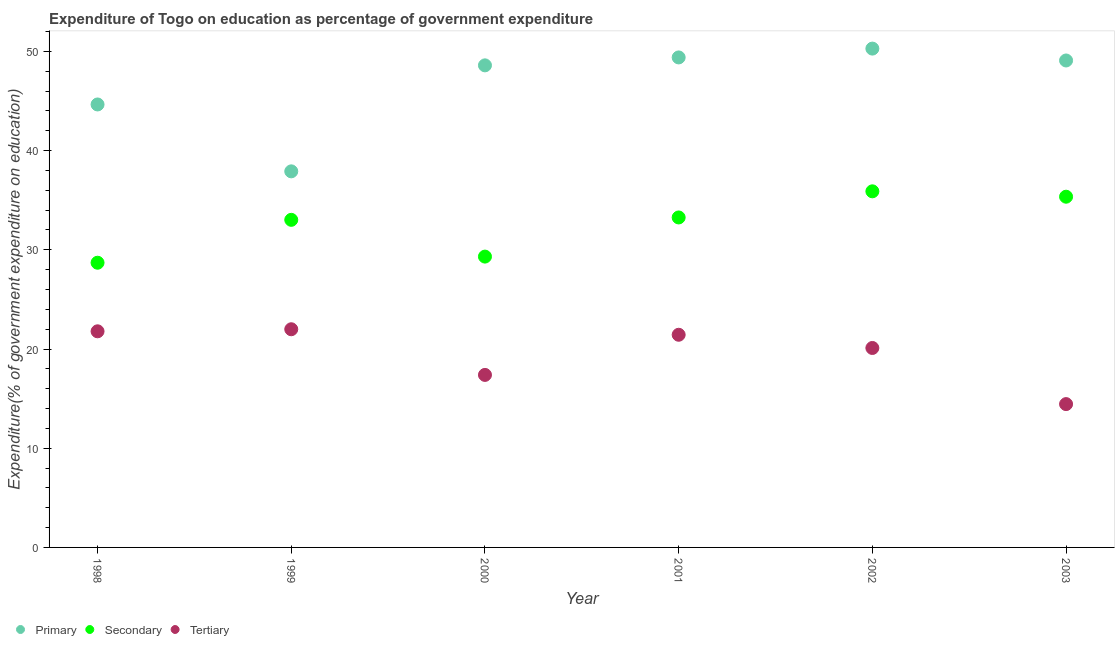What is the expenditure on secondary education in 1998?
Offer a terse response. 28.7. Across all years, what is the maximum expenditure on primary education?
Provide a short and direct response. 50.28. Across all years, what is the minimum expenditure on secondary education?
Your answer should be compact. 28.7. In which year was the expenditure on primary education minimum?
Offer a terse response. 1999. What is the total expenditure on primary education in the graph?
Your response must be concise. 279.89. What is the difference between the expenditure on secondary education in 2000 and that in 2001?
Provide a succinct answer. -3.95. What is the difference between the expenditure on primary education in 2001 and the expenditure on secondary education in 2000?
Ensure brevity in your answer.  20.08. What is the average expenditure on secondary education per year?
Give a very brief answer. 32.59. In the year 2000, what is the difference between the expenditure on secondary education and expenditure on primary education?
Your answer should be compact. -19.28. What is the ratio of the expenditure on tertiary education in 1999 to that in 2002?
Ensure brevity in your answer.  1.09. Is the expenditure on tertiary education in 2001 less than that in 2002?
Make the answer very short. No. What is the difference between the highest and the second highest expenditure on primary education?
Ensure brevity in your answer.  0.89. What is the difference between the highest and the lowest expenditure on secondary education?
Ensure brevity in your answer.  7.2. In how many years, is the expenditure on tertiary education greater than the average expenditure on tertiary education taken over all years?
Your answer should be compact. 4. Is it the case that in every year, the sum of the expenditure on primary education and expenditure on secondary education is greater than the expenditure on tertiary education?
Give a very brief answer. Yes. How many dotlines are there?
Your answer should be very brief. 3. How many years are there in the graph?
Your answer should be compact. 6. What is the difference between two consecutive major ticks on the Y-axis?
Ensure brevity in your answer.  10. Are the values on the major ticks of Y-axis written in scientific E-notation?
Keep it short and to the point. No. Does the graph contain grids?
Offer a terse response. No. Where does the legend appear in the graph?
Keep it short and to the point. Bottom left. How many legend labels are there?
Keep it short and to the point. 3. How are the legend labels stacked?
Your answer should be compact. Horizontal. What is the title of the graph?
Ensure brevity in your answer.  Expenditure of Togo on education as percentage of government expenditure. What is the label or title of the Y-axis?
Provide a succinct answer. Expenditure(% of government expenditure on education). What is the Expenditure(% of government expenditure on education) of Primary in 1998?
Ensure brevity in your answer.  44.65. What is the Expenditure(% of government expenditure on education) of Secondary in 1998?
Provide a short and direct response. 28.7. What is the Expenditure(% of government expenditure on education) of Tertiary in 1998?
Provide a short and direct response. 21.78. What is the Expenditure(% of government expenditure on education) of Primary in 1999?
Provide a short and direct response. 37.91. What is the Expenditure(% of government expenditure on education) in Secondary in 1999?
Offer a very short reply. 33.02. What is the Expenditure(% of government expenditure on education) of Tertiary in 1999?
Offer a terse response. 21.99. What is the Expenditure(% of government expenditure on education) in Primary in 2000?
Offer a very short reply. 48.59. What is the Expenditure(% of government expenditure on education) in Secondary in 2000?
Offer a terse response. 29.31. What is the Expenditure(% of government expenditure on education) in Tertiary in 2000?
Offer a terse response. 17.39. What is the Expenditure(% of government expenditure on education) of Primary in 2001?
Provide a succinct answer. 49.39. What is the Expenditure(% of government expenditure on education) of Secondary in 2001?
Provide a succinct answer. 33.26. What is the Expenditure(% of government expenditure on education) of Tertiary in 2001?
Provide a short and direct response. 21.43. What is the Expenditure(% of government expenditure on education) of Primary in 2002?
Offer a very short reply. 50.28. What is the Expenditure(% of government expenditure on education) of Secondary in 2002?
Keep it short and to the point. 35.89. What is the Expenditure(% of government expenditure on education) of Tertiary in 2002?
Offer a very short reply. 20.1. What is the Expenditure(% of government expenditure on education) of Primary in 2003?
Provide a short and direct response. 49.08. What is the Expenditure(% of government expenditure on education) in Secondary in 2003?
Provide a succinct answer. 35.35. What is the Expenditure(% of government expenditure on education) of Tertiary in 2003?
Ensure brevity in your answer.  14.45. Across all years, what is the maximum Expenditure(% of government expenditure on education) in Primary?
Your response must be concise. 50.28. Across all years, what is the maximum Expenditure(% of government expenditure on education) in Secondary?
Your answer should be compact. 35.89. Across all years, what is the maximum Expenditure(% of government expenditure on education) in Tertiary?
Your answer should be compact. 21.99. Across all years, what is the minimum Expenditure(% of government expenditure on education) in Primary?
Provide a short and direct response. 37.91. Across all years, what is the minimum Expenditure(% of government expenditure on education) in Secondary?
Your response must be concise. 28.7. Across all years, what is the minimum Expenditure(% of government expenditure on education) in Tertiary?
Ensure brevity in your answer.  14.45. What is the total Expenditure(% of government expenditure on education) in Primary in the graph?
Offer a terse response. 279.89. What is the total Expenditure(% of government expenditure on education) in Secondary in the graph?
Ensure brevity in your answer.  195.53. What is the total Expenditure(% of government expenditure on education) in Tertiary in the graph?
Offer a very short reply. 117.15. What is the difference between the Expenditure(% of government expenditure on education) in Primary in 1998 and that in 1999?
Your response must be concise. 6.74. What is the difference between the Expenditure(% of government expenditure on education) in Secondary in 1998 and that in 1999?
Provide a short and direct response. -4.32. What is the difference between the Expenditure(% of government expenditure on education) of Tertiary in 1998 and that in 1999?
Your response must be concise. -0.21. What is the difference between the Expenditure(% of government expenditure on education) in Primary in 1998 and that in 2000?
Offer a terse response. -3.94. What is the difference between the Expenditure(% of government expenditure on education) of Secondary in 1998 and that in 2000?
Your answer should be very brief. -0.62. What is the difference between the Expenditure(% of government expenditure on education) in Tertiary in 1998 and that in 2000?
Your response must be concise. 4.4. What is the difference between the Expenditure(% of government expenditure on education) of Primary in 1998 and that in 2001?
Make the answer very short. -4.74. What is the difference between the Expenditure(% of government expenditure on education) in Secondary in 1998 and that in 2001?
Offer a very short reply. -4.56. What is the difference between the Expenditure(% of government expenditure on education) of Tertiary in 1998 and that in 2001?
Make the answer very short. 0.35. What is the difference between the Expenditure(% of government expenditure on education) of Primary in 1998 and that in 2002?
Keep it short and to the point. -5.63. What is the difference between the Expenditure(% of government expenditure on education) in Secondary in 1998 and that in 2002?
Give a very brief answer. -7.2. What is the difference between the Expenditure(% of government expenditure on education) in Tertiary in 1998 and that in 2002?
Make the answer very short. 1.68. What is the difference between the Expenditure(% of government expenditure on education) in Primary in 1998 and that in 2003?
Provide a short and direct response. -4.43. What is the difference between the Expenditure(% of government expenditure on education) in Secondary in 1998 and that in 2003?
Offer a very short reply. -6.65. What is the difference between the Expenditure(% of government expenditure on education) of Tertiary in 1998 and that in 2003?
Ensure brevity in your answer.  7.34. What is the difference between the Expenditure(% of government expenditure on education) in Primary in 1999 and that in 2000?
Your response must be concise. -10.68. What is the difference between the Expenditure(% of government expenditure on education) of Secondary in 1999 and that in 2000?
Keep it short and to the point. 3.71. What is the difference between the Expenditure(% of government expenditure on education) of Tertiary in 1999 and that in 2000?
Offer a terse response. 4.6. What is the difference between the Expenditure(% of government expenditure on education) in Primary in 1999 and that in 2001?
Provide a short and direct response. -11.48. What is the difference between the Expenditure(% of government expenditure on education) in Secondary in 1999 and that in 2001?
Offer a terse response. -0.24. What is the difference between the Expenditure(% of government expenditure on education) of Tertiary in 1999 and that in 2001?
Ensure brevity in your answer.  0.56. What is the difference between the Expenditure(% of government expenditure on education) in Primary in 1999 and that in 2002?
Provide a short and direct response. -12.37. What is the difference between the Expenditure(% of government expenditure on education) of Secondary in 1999 and that in 2002?
Your response must be concise. -2.87. What is the difference between the Expenditure(% of government expenditure on education) in Tertiary in 1999 and that in 2002?
Your response must be concise. 1.89. What is the difference between the Expenditure(% of government expenditure on education) in Primary in 1999 and that in 2003?
Your response must be concise. -11.17. What is the difference between the Expenditure(% of government expenditure on education) in Secondary in 1999 and that in 2003?
Give a very brief answer. -2.33. What is the difference between the Expenditure(% of government expenditure on education) in Tertiary in 1999 and that in 2003?
Your response must be concise. 7.54. What is the difference between the Expenditure(% of government expenditure on education) of Primary in 2000 and that in 2001?
Offer a terse response. -0.8. What is the difference between the Expenditure(% of government expenditure on education) in Secondary in 2000 and that in 2001?
Your answer should be compact. -3.95. What is the difference between the Expenditure(% of government expenditure on education) in Tertiary in 2000 and that in 2001?
Your answer should be compact. -4.05. What is the difference between the Expenditure(% of government expenditure on education) in Primary in 2000 and that in 2002?
Provide a succinct answer. -1.69. What is the difference between the Expenditure(% of government expenditure on education) of Secondary in 2000 and that in 2002?
Provide a succinct answer. -6.58. What is the difference between the Expenditure(% of government expenditure on education) in Tertiary in 2000 and that in 2002?
Your response must be concise. -2.71. What is the difference between the Expenditure(% of government expenditure on education) in Primary in 2000 and that in 2003?
Offer a terse response. -0.49. What is the difference between the Expenditure(% of government expenditure on education) in Secondary in 2000 and that in 2003?
Your response must be concise. -6.04. What is the difference between the Expenditure(% of government expenditure on education) of Tertiary in 2000 and that in 2003?
Keep it short and to the point. 2.94. What is the difference between the Expenditure(% of government expenditure on education) of Primary in 2001 and that in 2002?
Make the answer very short. -0.89. What is the difference between the Expenditure(% of government expenditure on education) in Secondary in 2001 and that in 2002?
Offer a very short reply. -2.63. What is the difference between the Expenditure(% of government expenditure on education) of Tertiary in 2001 and that in 2002?
Your answer should be compact. 1.33. What is the difference between the Expenditure(% of government expenditure on education) of Primary in 2001 and that in 2003?
Offer a very short reply. 0.31. What is the difference between the Expenditure(% of government expenditure on education) in Secondary in 2001 and that in 2003?
Provide a succinct answer. -2.09. What is the difference between the Expenditure(% of government expenditure on education) of Tertiary in 2001 and that in 2003?
Provide a short and direct response. 6.99. What is the difference between the Expenditure(% of government expenditure on education) in Primary in 2002 and that in 2003?
Offer a very short reply. 1.2. What is the difference between the Expenditure(% of government expenditure on education) in Secondary in 2002 and that in 2003?
Keep it short and to the point. 0.54. What is the difference between the Expenditure(% of government expenditure on education) in Tertiary in 2002 and that in 2003?
Offer a very short reply. 5.66. What is the difference between the Expenditure(% of government expenditure on education) of Primary in 1998 and the Expenditure(% of government expenditure on education) of Secondary in 1999?
Keep it short and to the point. 11.63. What is the difference between the Expenditure(% of government expenditure on education) of Primary in 1998 and the Expenditure(% of government expenditure on education) of Tertiary in 1999?
Your answer should be compact. 22.66. What is the difference between the Expenditure(% of government expenditure on education) in Secondary in 1998 and the Expenditure(% of government expenditure on education) in Tertiary in 1999?
Provide a succinct answer. 6.71. What is the difference between the Expenditure(% of government expenditure on education) of Primary in 1998 and the Expenditure(% of government expenditure on education) of Secondary in 2000?
Your answer should be very brief. 15.33. What is the difference between the Expenditure(% of government expenditure on education) of Primary in 1998 and the Expenditure(% of government expenditure on education) of Tertiary in 2000?
Ensure brevity in your answer.  27.26. What is the difference between the Expenditure(% of government expenditure on education) in Secondary in 1998 and the Expenditure(% of government expenditure on education) in Tertiary in 2000?
Your answer should be compact. 11.31. What is the difference between the Expenditure(% of government expenditure on education) in Primary in 1998 and the Expenditure(% of government expenditure on education) in Secondary in 2001?
Give a very brief answer. 11.39. What is the difference between the Expenditure(% of government expenditure on education) in Primary in 1998 and the Expenditure(% of government expenditure on education) in Tertiary in 2001?
Your answer should be very brief. 23.21. What is the difference between the Expenditure(% of government expenditure on education) of Secondary in 1998 and the Expenditure(% of government expenditure on education) of Tertiary in 2001?
Offer a terse response. 7.26. What is the difference between the Expenditure(% of government expenditure on education) of Primary in 1998 and the Expenditure(% of government expenditure on education) of Secondary in 2002?
Offer a terse response. 8.75. What is the difference between the Expenditure(% of government expenditure on education) in Primary in 1998 and the Expenditure(% of government expenditure on education) in Tertiary in 2002?
Keep it short and to the point. 24.55. What is the difference between the Expenditure(% of government expenditure on education) of Secondary in 1998 and the Expenditure(% of government expenditure on education) of Tertiary in 2002?
Give a very brief answer. 8.59. What is the difference between the Expenditure(% of government expenditure on education) of Primary in 1998 and the Expenditure(% of government expenditure on education) of Secondary in 2003?
Your answer should be very brief. 9.3. What is the difference between the Expenditure(% of government expenditure on education) in Primary in 1998 and the Expenditure(% of government expenditure on education) in Tertiary in 2003?
Offer a very short reply. 30.2. What is the difference between the Expenditure(% of government expenditure on education) in Secondary in 1998 and the Expenditure(% of government expenditure on education) in Tertiary in 2003?
Your answer should be very brief. 14.25. What is the difference between the Expenditure(% of government expenditure on education) in Primary in 1999 and the Expenditure(% of government expenditure on education) in Secondary in 2000?
Keep it short and to the point. 8.59. What is the difference between the Expenditure(% of government expenditure on education) in Primary in 1999 and the Expenditure(% of government expenditure on education) in Tertiary in 2000?
Make the answer very short. 20.52. What is the difference between the Expenditure(% of government expenditure on education) of Secondary in 1999 and the Expenditure(% of government expenditure on education) of Tertiary in 2000?
Your answer should be compact. 15.63. What is the difference between the Expenditure(% of government expenditure on education) of Primary in 1999 and the Expenditure(% of government expenditure on education) of Secondary in 2001?
Your answer should be very brief. 4.65. What is the difference between the Expenditure(% of government expenditure on education) in Primary in 1999 and the Expenditure(% of government expenditure on education) in Tertiary in 2001?
Provide a short and direct response. 16.47. What is the difference between the Expenditure(% of government expenditure on education) in Secondary in 1999 and the Expenditure(% of government expenditure on education) in Tertiary in 2001?
Give a very brief answer. 11.58. What is the difference between the Expenditure(% of government expenditure on education) in Primary in 1999 and the Expenditure(% of government expenditure on education) in Secondary in 2002?
Make the answer very short. 2.01. What is the difference between the Expenditure(% of government expenditure on education) in Primary in 1999 and the Expenditure(% of government expenditure on education) in Tertiary in 2002?
Provide a short and direct response. 17.8. What is the difference between the Expenditure(% of government expenditure on education) in Secondary in 1999 and the Expenditure(% of government expenditure on education) in Tertiary in 2002?
Your response must be concise. 12.92. What is the difference between the Expenditure(% of government expenditure on education) of Primary in 1999 and the Expenditure(% of government expenditure on education) of Secondary in 2003?
Give a very brief answer. 2.56. What is the difference between the Expenditure(% of government expenditure on education) in Primary in 1999 and the Expenditure(% of government expenditure on education) in Tertiary in 2003?
Make the answer very short. 23.46. What is the difference between the Expenditure(% of government expenditure on education) in Secondary in 1999 and the Expenditure(% of government expenditure on education) in Tertiary in 2003?
Provide a short and direct response. 18.57. What is the difference between the Expenditure(% of government expenditure on education) in Primary in 2000 and the Expenditure(% of government expenditure on education) in Secondary in 2001?
Keep it short and to the point. 15.33. What is the difference between the Expenditure(% of government expenditure on education) of Primary in 2000 and the Expenditure(% of government expenditure on education) of Tertiary in 2001?
Provide a succinct answer. 27.15. What is the difference between the Expenditure(% of government expenditure on education) of Secondary in 2000 and the Expenditure(% of government expenditure on education) of Tertiary in 2001?
Make the answer very short. 7.88. What is the difference between the Expenditure(% of government expenditure on education) in Primary in 2000 and the Expenditure(% of government expenditure on education) in Secondary in 2002?
Your response must be concise. 12.7. What is the difference between the Expenditure(% of government expenditure on education) of Primary in 2000 and the Expenditure(% of government expenditure on education) of Tertiary in 2002?
Ensure brevity in your answer.  28.49. What is the difference between the Expenditure(% of government expenditure on education) in Secondary in 2000 and the Expenditure(% of government expenditure on education) in Tertiary in 2002?
Your response must be concise. 9.21. What is the difference between the Expenditure(% of government expenditure on education) of Primary in 2000 and the Expenditure(% of government expenditure on education) of Secondary in 2003?
Offer a terse response. 13.24. What is the difference between the Expenditure(% of government expenditure on education) of Primary in 2000 and the Expenditure(% of government expenditure on education) of Tertiary in 2003?
Your answer should be compact. 34.14. What is the difference between the Expenditure(% of government expenditure on education) in Secondary in 2000 and the Expenditure(% of government expenditure on education) in Tertiary in 2003?
Your response must be concise. 14.87. What is the difference between the Expenditure(% of government expenditure on education) of Primary in 2001 and the Expenditure(% of government expenditure on education) of Secondary in 2002?
Your response must be concise. 13.5. What is the difference between the Expenditure(% of government expenditure on education) in Primary in 2001 and the Expenditure(% of government expenditure on education) in Tertiary in 2002?
Your answer should be very brief. 29.29. What is the difference between the Expenditure(% of government expenditure on education) in Secondary in 2001 and the Expenditure(% of government expenditure on education) in Tertiary in 2002?
Ensure brevity in your answer.  13.16. What is the difference between the Expenditure(% of government expenditure on education) of Primary in 2001 and the Expenditure(% of government expenditure on education) of Secondary in 2003?
Provide a succinct answer. 14.04. What is the difference between the Expenditure(% of government expenditure on education) of Primary in 2001 and the Expenditure(% of government expenditure on education) of Tertiary in 2003?
Give a very brief answer. 34.94. What is the difference between the Expenditure(% of government expenditure on education) of Secondary in 2001 and the Expenditure(% of government expenditure on education) of Tertiary in 2003?
Give a very brief answer. 18.81. What is the difference between the Expenditure(% of government expenditure on education) of Primary in 2002 and the Expenditure(% of government expenditure on education) of Secondary in 2003?
Offer a terse response. 14.93. What is the difference between the Expenditure(% of government expenditure on education) in Primary in 2002 and the Expenditure(% of government expenditure on education) in Tertiary in 2003?
Keep it short and to the point. 35.83. What is the difference between the Expenditure(% of government expenditure on education) in Secondary in 2002 and the Expenditure(% of government expenditure on education) in Tertiary in 2003?
Provide a short and direct response. 21.45. What is the average Expenditure(% of government expenditure on education) in Primary per year?
Give a very brief answer. 46.65. What is the average Expenditure(% of government expenditure on education) in Secondary per year?
Give a very brief answer. 32.59. What is the average Expenditure(% of government expenditure on education) of Tertiary per year?
Provide a succinct answer. 19.52. In the year 1998, what is the difference between the Expenditure(% of government expenditure on education) of Primary and Expenditure(% of government expenditure on education) of Secondary?
Offer a terse response. 15.95. In the year 1998, what is the difference between the Expenditure(% of government expenditure on education) in Primary and Expenditure(% of government expenditure on education) in Tertiary?
Provide a succinct answer. 22.86. In the year 1998, what is the difference between the Expenditure(% of government expenditure on education) in Secondary and Expenditure(% of government expenditure on education) in Tertiary?
Give a very brief answer. 6.91. In the year 1999, what is the difference between the Expenditure(% of government expenditure on education) in Primary and Expenditure(% of government expenditure on education) in Secondary?
Provide a short and direct response. 4.89. In the year 1999, what is the difference between the Expenditure(% of government expenditure on education) in Primary and Expenditure(% of government expenditure on education) in Tertiary?
Offer a very short reply. 15.92. In the year 1999, what is the difference between the Expenditure(% of government expenditure on education) in Secondary and Expenditure(% of government expenditure on education) in Tertiary?
Offer a terse response. 11.03. In the year 2000, what is the difference between the Expenditure(% of government expenditure on education) of Primary and Expenditure(% of government expenditure on education) of Secondary?
Give a very brief answer. 19.28. In the year 2000, what is the difference between the Expenditure(% of government expenditure on education) of Primary and Expenditure(% of government expenditure on education) of Tertiary?
Your answer should be compact. 31.2. In the year 2000, what is the difference between the Expenditure(% of government expenditure on education) in Secondary and Expenditure(% of government expenditure on education) in Tertiary?
Your answer should be very brief. 11.92. In the year 2001, what is the difference between the Expenditure(% of government expenditure on education) of Primary and Expenditure(% of government expenditure on education) of Secondary?
Provide a succinct answer. 16.13. In the year 2001, what is the difference between the Expenditure(% of government expenditure on education) in Primary and Expenditure(% of government expenditure on education) in Tertiary?
Offer a terse response. 27.95. In the year 2001, what is the difference between the Expenditure(% of government expenditure on education) of Secondary and Expenditure(% of government expenditure on education) of Tertiary?
Keep it short and to the point. 11.82. In the year 2002, what is the difference between the Expenditure(% of government expenditure on education) in Primary and Expenditure(% of government expenditure on education) in Secondary?
Offer a terse response. 14.39. In the year 2002, what is the difference between the Expenditure(% of government expenditure on education) of Primary and Expenditure(% of government expenditure on education) of Tertiary?
Give a very brief answer. 30.18. In the year 2002, what is the difference between the Expenditure(% of government expenditure on education) of Secondary and Expenditure(% of government expenditure on education) of Tertiary?
Offer a very short reply. 15.79. In the year 2003, what is the difference between the Expenditure(% of government expenditure on education) in Primary and Expenditure(% of government expenditure on education) in Secondary?
Your answer should be compact. 13.73. In the year 2003, what is the difference between the Expenditure(% of government expenditure on education) in Primary and Expenditure(% of government expenditure on education) in Tertiary?
Your response must be concise. 34.63. In the year 2003, what is the difference between the Expenditure(% of government expenditure on education) in Secondary and Expenditure(% of government expenditure on education) in Tertiary?
Offer a terse response. 20.9. What is the ratio of the Expenditure(% of government expenditure on education) in Primary in 1998 to that in 1999?
Offer a very short reply. 1.18. What is the ratio of the Expenditure(% of government expenditure on education) in Secondary in 1998 to that in 1999?
Your answer should be compact. 0.87. What is the ratio of the Expenditure(% of government expenditure on education) of Tertiary in 1998 to that in 1999?
Keep it short and to the point. 0.99. What is the ratio of the Expenditure(% of government expenditure on education) of Primary in 1998 to that in 2000?
Provide a short and direct response. 0.92. What is the ratio of the Expenditure(% of government expenditure on education) in Secondary in 1998 to that in 2000?
Offer a very short reply. 0.98. What is the ratio of the Expenditure(% of government expenditure on education) in Tertiary in 1998 to that in 2000?
Provide a short and direct response. 1.25. What is the ratio of the Expenditure(% of government expenditure on education) in Primary in 1998 to that in 2001?
Your answer should be compact. 0.9. What is the ratio of the Expenditure(% of government expenditure on education) of Secondary in 1998 to that in 2001?
Offer a very short reply. 0.86. What is the ratio of the Expenditure(% of government expenditure on education) in Tertiary in 1998 to that in 2001?
Give a very brief answer. 1.02. What is the ratio of the Expenditure(% of government expenditure on education) of Primary in 1998 to that in 2002?
Provide a succinct answer. 0.89. What is the ratio of the Expenditure(% of government expenditure on education) of Secondary in 1998 to that in 2002?
Offer a terse response. 0.8. What is the ratio of the Expenditure(% of government expenditure on education) of Tertiary in 1998 to that in 2002?
Offer a terse response. 1.08. What is the ratio of the Expenditure(% of government expenditure on education) of Primary in 1998 to that in 2003?
Make the answer very short. 0.91. What is the ratio of the Expenditure(% of government expenditure on education) of Secondary in 1998 to that in 2003?
Your response must be concise. 0.81. What is the ratio of the Expenditure(% of government expenditure on education) in Tertiary in 1998 to that in 2003?
Offer a very short reply. 1.51. What is the ratio of the Expenditure(% of government expenditure on education) of Primary in 1999 to that in 2000?
Your answer should be compact. 0.78. What is the ratio of the Expenditure(% of government expenditure on education) in Secondary in 1999 to that in 2000?
Your answer should be very brief. 1.13. What is the ratio of the Expenditure(% of government expenditure on education) in Tertiary in 1999 to that in 2000?
Your answer should be very brief. 1.26. What is the ratio of the Expenditure(% of government expenditure on education) in Primary in 1999 to that in 2001?
Give a very brief answer. 0.77. What is the ratio of the Expenditure(% of government expenditure on education) in Secondary in 1999 to that in 2001?
Offer a very short reply. 0.99. What is the ratio of the Expenditure(% of government expenditure on education) in Tertiary in 1999 to that in 2001?
Give a very brief answer. 1.03. What is the ratio of the Expenditure(% of government expenditure on education) of Primary in 1999 to that in 2002?
Your response must be concise. 0.75. What is the ratio of the Expenditure(% of government expenditure on education) of Secondary in 1999 to that in 2002?
Keep it short and to the point. 0.92. What is the ratio of the Expenditure(% of government expenditure on education) of Tertiary in 1999 to that in 2002?
Your answer should be compact. 1.09. What is the ratio of the Expenditure(% of government expenditure on education) in Primary in 1999 to that in 2003?
Ensure brevity in your answer.  0.77. What is the ratio of the Expenditure(% of government expenditure on education) in Secondary in 1999 to that in 2003?
Make the answer very short. 0.93. What is the ratio of the Expenditure(% of government expenditure on education) in Tertiary in 1999 to that in 2003?
Ensure brevity in your answer.  1.52. What is the ratio of the Expenditure(% of government expenditure on education) in Primary in 2000 to that in 2001?
Keep it short and to the point. 0.98. What is the ratio of the Expenditure(% of government expenditure on education) in Secondary in 2000 to that in 2001?
Offer a very short reply. 0.88. What is the ratio of the Expenditure(% of government expenditure on education) of Tertiary in 2000 to that in 2001?
Make the answer very short. 0.81. What is the ratio of the Expenditure(% of government expenditure on education) in Primary in 2000 to that in 2002?
Your answer should be compact. 0.97. What is the ratio of the Expenditure(% of government expenditure on education) of Secondary in 2000 to that in 2002?
Ensure brevity in your answer.  0.82. What is the ratio of the Expenditure(% of government expenditure on education) in Tertiary in 2000 to that in 2002?
Make the answer very short. 0.86. What is the ratio of the Expenditure(% of government expenditure on education) in Primary in 2000 to that in 2003?
Offer a terse response. 0.99. What is the ratio of the Expenditure(% of government expenditure on education) of Secondary in 2000 to that in 2003?
Make the answer very short. 0.83. What is the ratio of the Expenditure(% of government expenditure on education) in Tertiary in 2000 to that in 2003?
Provide a short and direct response. 1.2. What is the ratio of the Expenditure(% of government expenditure on education) in Primary in 2001 to that in 2002?
Provide a short and direct response. 0.98. What is the ratio of the Expenditure(% of government expenditure on education) in Secondary in 2001 to that in 2002?
Your answer should be very brief. 0.93. What is the ratio of the Expenditure(% of government expenditure on education) in Tertiary in 2001 to that in 2002?
Offer a terse response. 1.07. What is the ratio of the Expenditure(% of government expenditure on education) of Secondary in 2001 to that in 2003?
Give a very brief answer. 0.94. What is the ratio of the Expenditure(% of government expenditure on education) of Tertiary in 2001 to that in 2003?
Your answer should be very brief. 1.48. What is the ratio of the Expenditure(% of government expenditure on education) in Primary in 2002 to that in 2003?
Offer a very short reply. 1.02. What is the ratio of the Expenditure(% of government expenditure on education) in Secondary in 2002 to that in 2003?
Your answer should be compact. 1.02. What is the ratio of the Expenditure(% of government expenditure on education) in Tertiary in 2002 to that in 2003?
Your response must be concise. 1.39. What is the difference between the highest and the second highest Expenditure(% of government expenditure on education) in Primary?
Provide a succinct answer. 0.89. What is the difference between the highest and the second highest Expenditure(% of government expenditure on education) of Secondary?
Give a very brief answer. 0.54. What is the difference between the highest and the second highest Expenditure(% of government expenditure on education) of Tertiary?
Provide a succinct answer. 0.21. What is the difference between the highest and the lowest Expenditure(% of government expenditure on education) of Primary?
Offer a very short reply. 12.37. What is the difference between the highest and the lowest Expenditure(% of government expenditure on education) of Secondary?
Make the answer very short. 7.2. What is the difference between the highest and the lowest Expenditure(% of government expenditure on education) in Tertiary?
Your answer should be very brief. 7.54. 